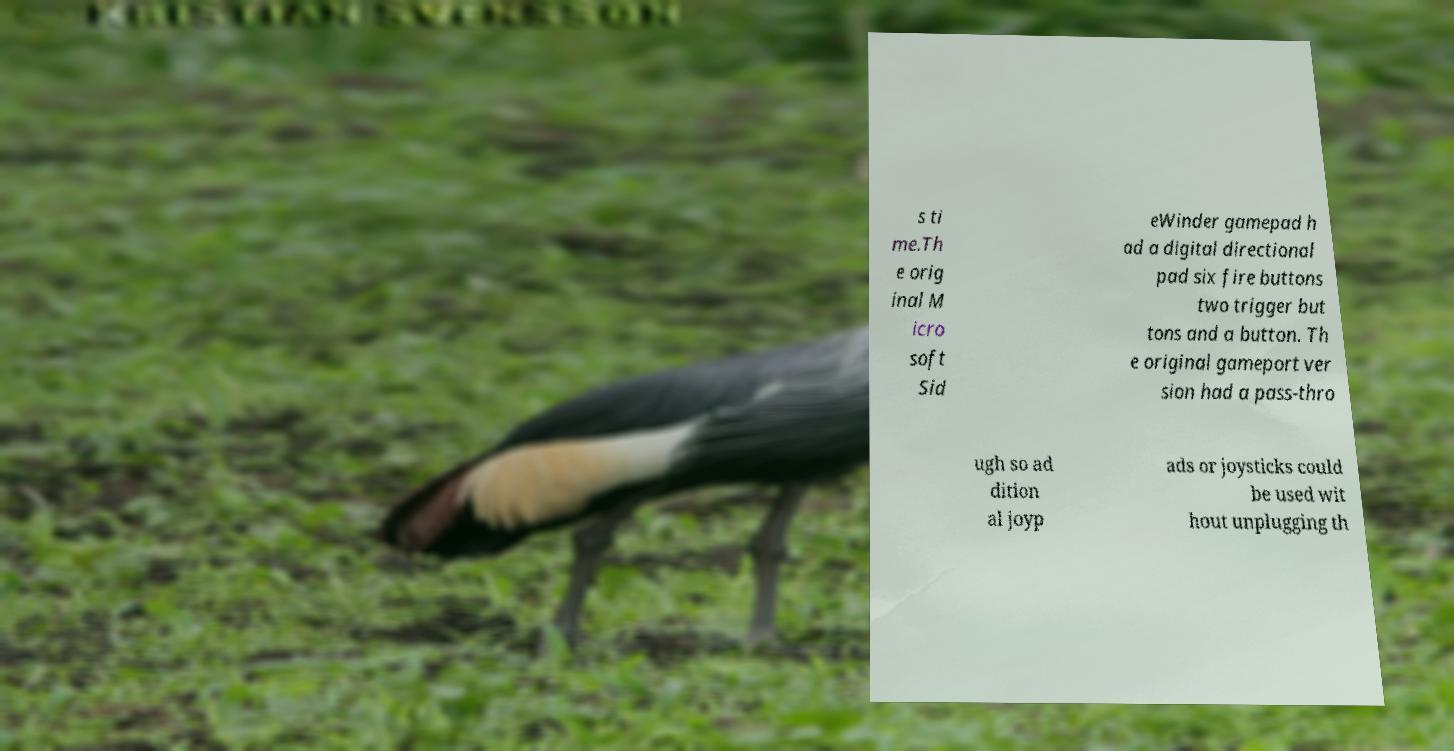What messages or text are displayed in this image? I need them in a readable, typed format. s ti me.Th e orig inal M icro soft Sid eWinder gamepad h ad a digital directional pad six fire buttons two trigger but tons and a button. Th e original gameport ver sion had a pass-thro ugh so ad dition al joyp ads or joysticks could be used wit hout unplugging th 